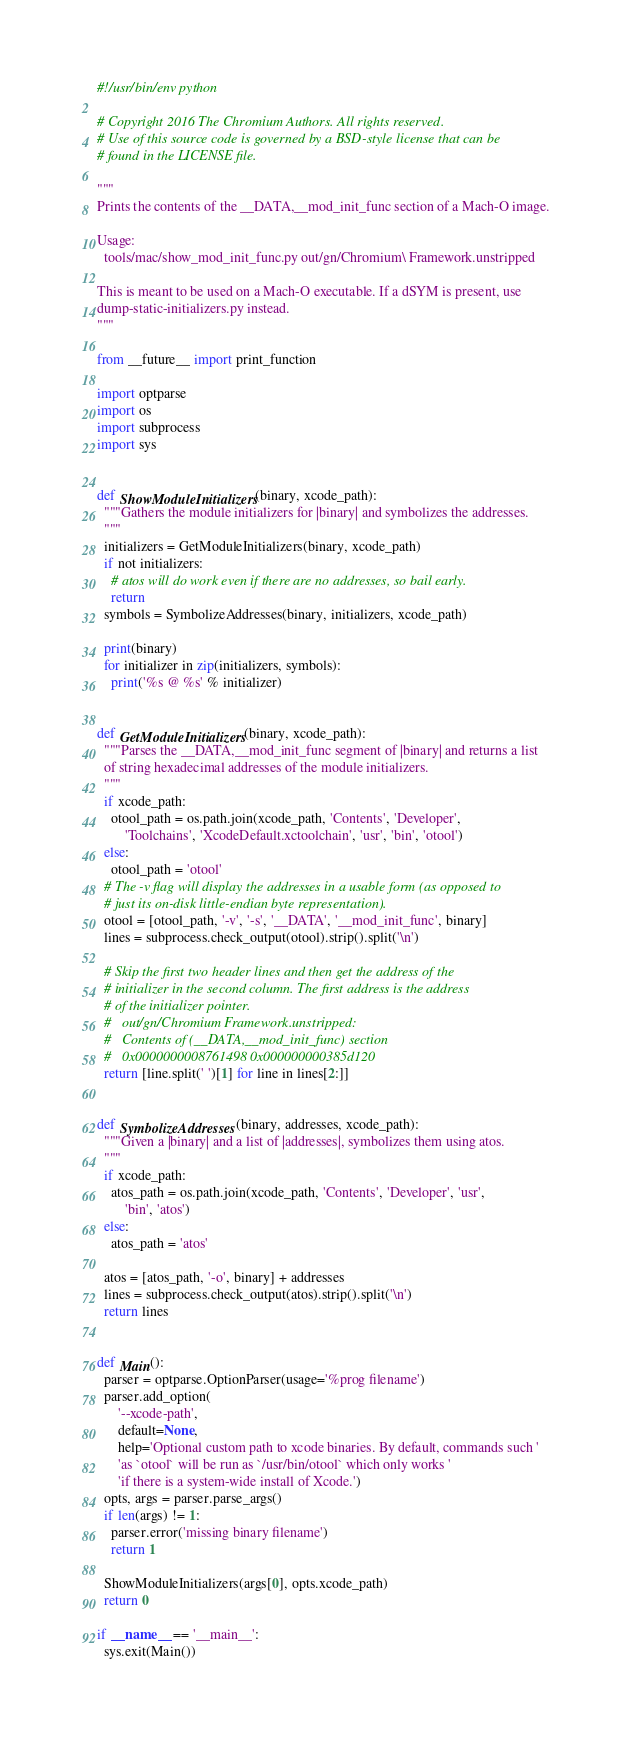Convert code to text. <code><loc_0><loc_0><loc_500><loc_500><_Python_>#!/usr/bin/env python

# Copyright 2016 The Chromium Authors. All rights reserved.
# Use of this source code is governed by a BSD-style license that can be
# found in the LICENSE file.

"""
Prints the contents of the __DATA,__mod_init_func section of a Mach-O image.

Usage:
  tools/mac/show_mod_init_func.py out/gn/Chromium\ Framework.unstripped

This is meant to be used on a Mach-O executable. If a dSYM is present, use
dump-static-initializers.py instead.
"""

from __future__ import print_function

import optparse
import os
import subprocess
import sys


def ShowModuleInitializers(binary, xcode_path):
  """Gathers the module initializers for |binary| and symbolizes the addresses.
  """
  initializers = GetModuleInitializers(binary, xcode_path)
  if not initializers:
    # atos will do work even if there are no addresses, so bail early.
    return
  symbols = SymbolizeAddresses(binary, initializers, xcode_path)

  print(binary)
  for initializer in zip(initializers, symbols):
    print('%s @ %s' % initializer)


def GetModuleInitializers(binary, xcode_path):
  """Parses the __DATA,__mod_init_func segment of |binary| and returns a list
  of string hexadecimal addresses of the module initializers.
  """
  if xcode_path:
    otool_path = os.path.join(xcode_path, 'Contents', 'Developer',
        'Toolchains', 'XcodeDefault.xctoolchain', 'usr', 'bin', 'otool')
  else:
    otool_path = 'otool'
  # The -v flag will display the addresses in a usable form (as opposed to
  # just its on-disk little-endian byte representation).
  otool = [otool_path, '-v', '-s', '__DATA', '__mod_init_func', binary]
  lines = subprocess.check_output(otool).strip().split('\n')

  # Skip the first two header lines and then get the address of the
  # initializer in the second column. The first address is the address
  # of the initializer pointer.
  #   out/gn/Chromium Framework.unstripped:
  #   Contents of (__DATA,__mod_init_func) section
  #   0x0000000008761498 0x000000000385d120
  return [line.split(' ')[1] for line in lines[2:]]


def SymbolizeAddresses(binary, addresses, xcode_path):
  """Given a |binary| and a list of |addresses|, symbolizes them using atos.
  """
  if xcode_path:
    atos_path = os.path.join(xcode_path, 'Contents', 'Developer', 'usr',
        'bin', 'atos')
  else:
    atos_path = 'atos'

  atos = [atos_path, '-o', binary] + addresses
  lines = subprocess.check_output(atos).strip().split('\n')
  return lines


def Main():
  parser = optparse.OptionParser(usage='%prog filename')
  parser.add_option(
      '--xcode-path',
      default=None,
      help='Optional custom path to xcode binaries. By default, commands such '
      'as `otool` will be run as `/usr/bin/otool` which only works '
      'if there is a system-wide install of Xcode.')
  opts, args = parser.parse_args()
  if len(args) != 1:
    parser.error('missing binary filename')
    return 1

  ShowModuleInitializers(args[0], opts.xcode_path)
  return 0

if __name__ == '__main__':
  sys.exit(Main())
</code> 